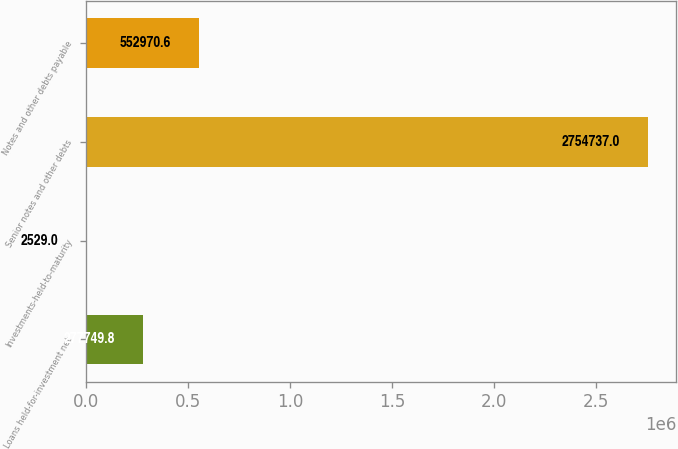<chart> <loc_0><loc_0><loc_500><loc_500><bar_chart><fcel>Loans held-for-investment net<fcel>Investments-held-to-maturity<fcel>Senior notes and other debts<fcel>Notes and other debts payable<nl><fcel>277750<fcel>2529<fcel>2.75474e+06<fcel>552971<nl></chart> 